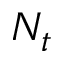Convert formula to latex. <formula><loc_0><loc_0><loc_500><loc_500>N _ { t }</formula> 